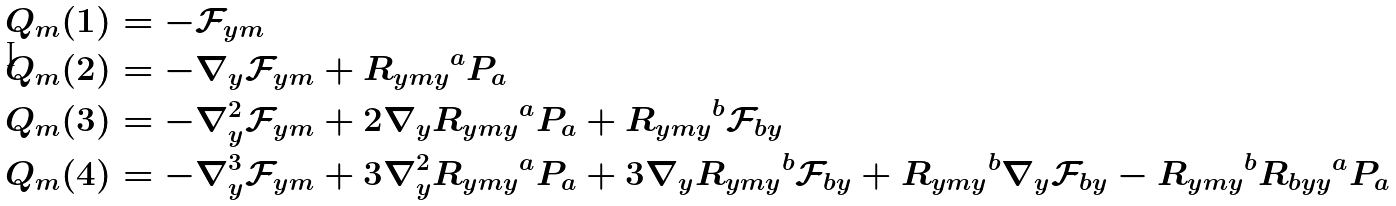Convert formula to latex. <formula><loc_0><loc_0><loc_500><loc_500>Q _ { m } ( 1 ) & = - { \mathcal { F } _ { y m } } \\ Q _ { m } ( 2 ) & = - \nabla _ { y } { \mathcal { F } _ { y m } } + { R _ { y m y } } ^ { a } P _ { a } \\ Q _ { m } ( 3 ) & = - \nabla _ { y } ^ { 2 } { \mathcal { F } _ { y m } } + 2 \nabla _ { y } { R _ { y m y } } ^ { a } P _ { a } + { R _ { y m y } } ^ { b } \mathcal { F } _ { b y } \\ Q _ { m } ( 4 ) & = - \nabla _ { y } ^ { 3 } { \mathcal { F } _ { y m } } + 3 \nabla _ { y } ^ { 2 } { R _ { y m y } } ^ { a } P _ { a } + 3 \nabla _ { y } { R _ { y m y } } ^ { b } \mathcal { F } _ { b y } + { R _ { y m y } } ^ { b } \nabla _ { y } \mathcal { F } _ { b y } - { R _ { y m y } } ^ { b } { R _ { b y y } } ^ { a } P _ { a }</formula> 